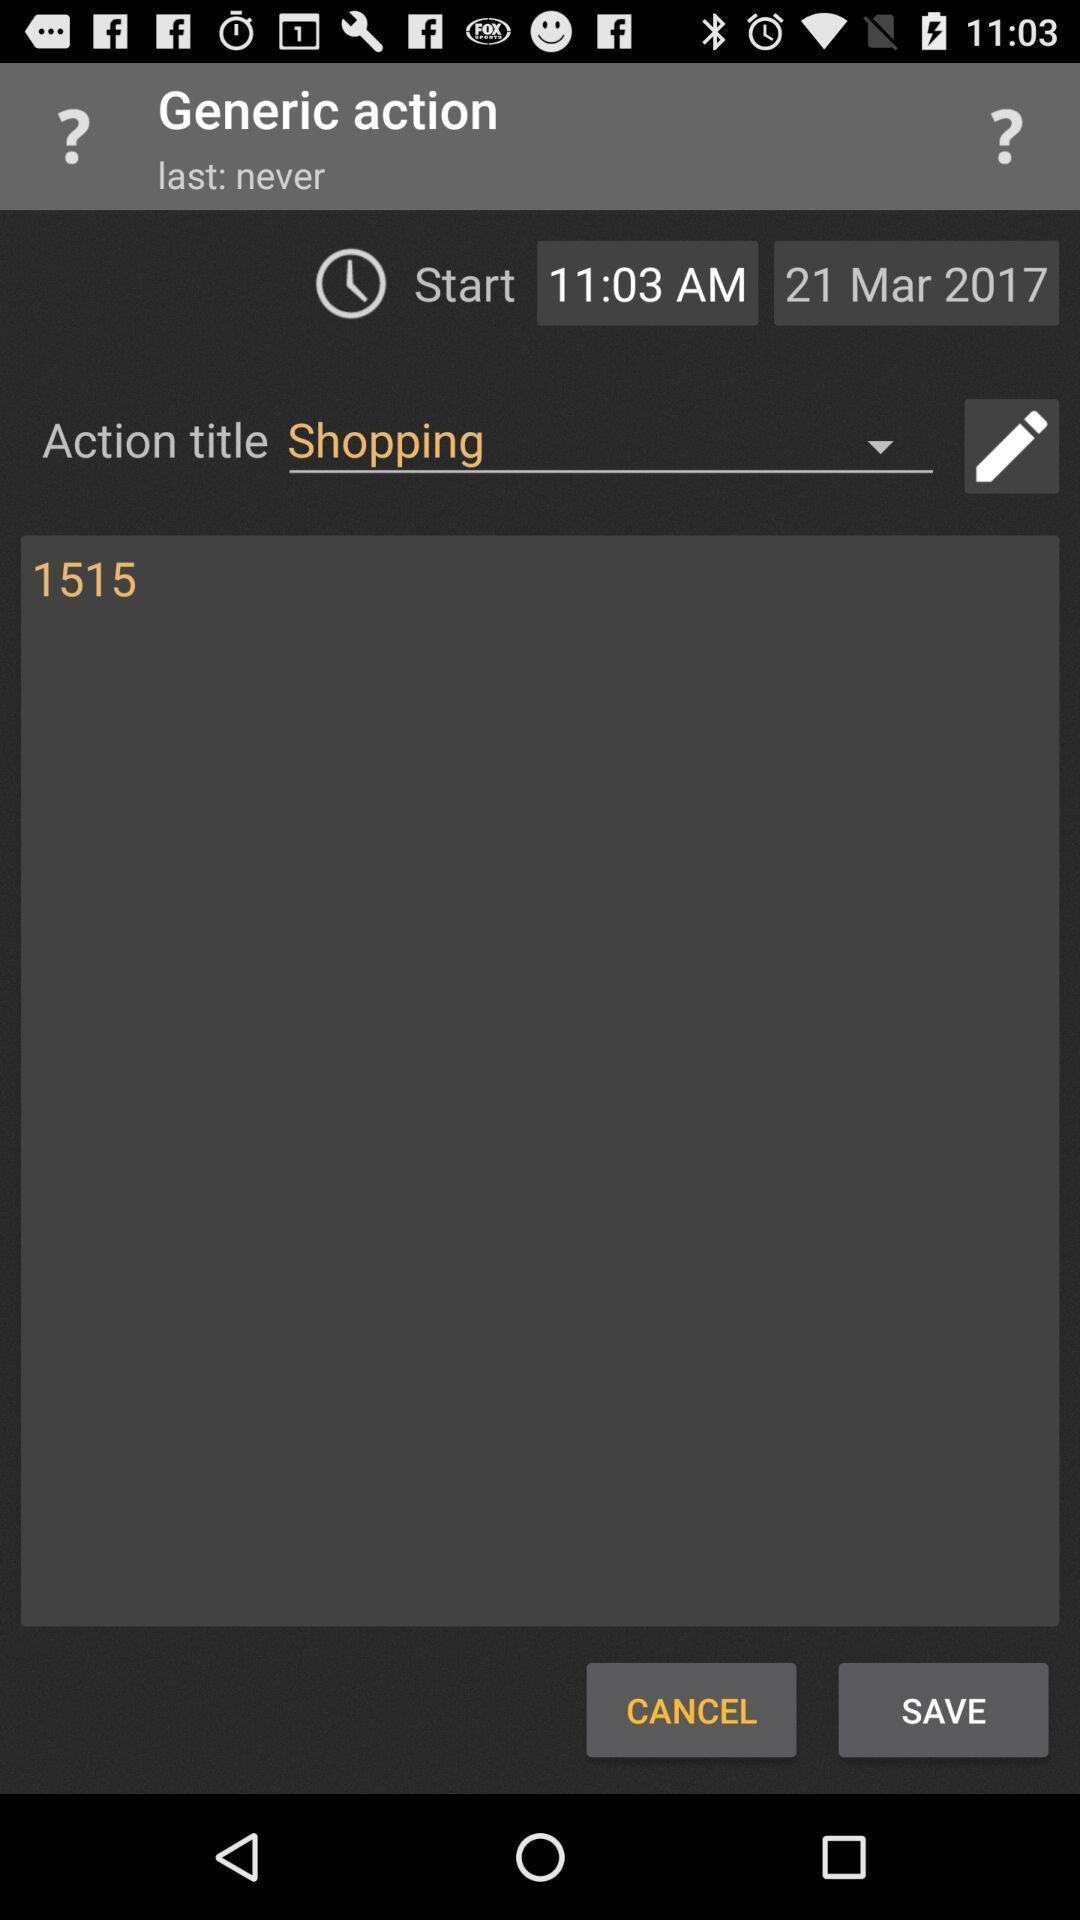Provide a detailed account of this screenshot. Screen shows generic action. 